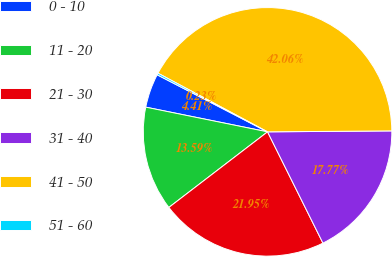Convert chart. <chart><loc_0><loc_0><loc_500><loc_500><pie_chart><fcel>0 - 10<fcel>11 - 20<fcel>21 - 30<fcel>31 - 40<fcel>41 - 50<fcel>51 - 60<nl><fcel>4.41%<fcel>13.59%<fcel>21.95%<fcel>17.77%<fcel>42.06%<fcel>0.23%<nl></chart> 